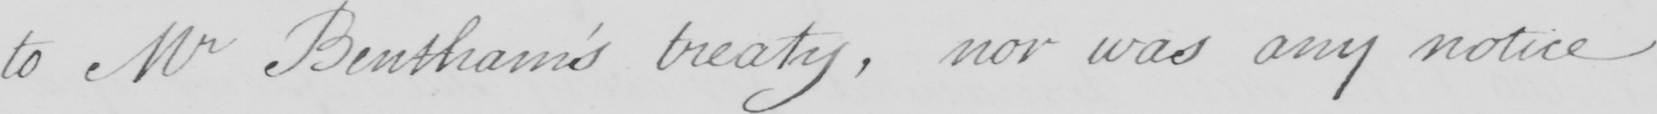Can you read and transcribe this handwriting? to Mr Bentham ' s treaty , nor was any notice 